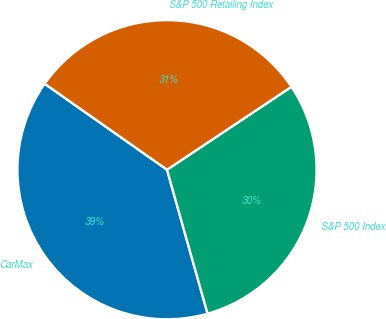<chart> <loc_0><loc_0><loc_500><loc_500><pie_chart><fcel>CarMax<fcel>S&P 500 Index<fcel>S&P 500 Retailing Index<nl><fcel>39.12%<fcel>29.98%<fcel>30.9%<nl></chart> 